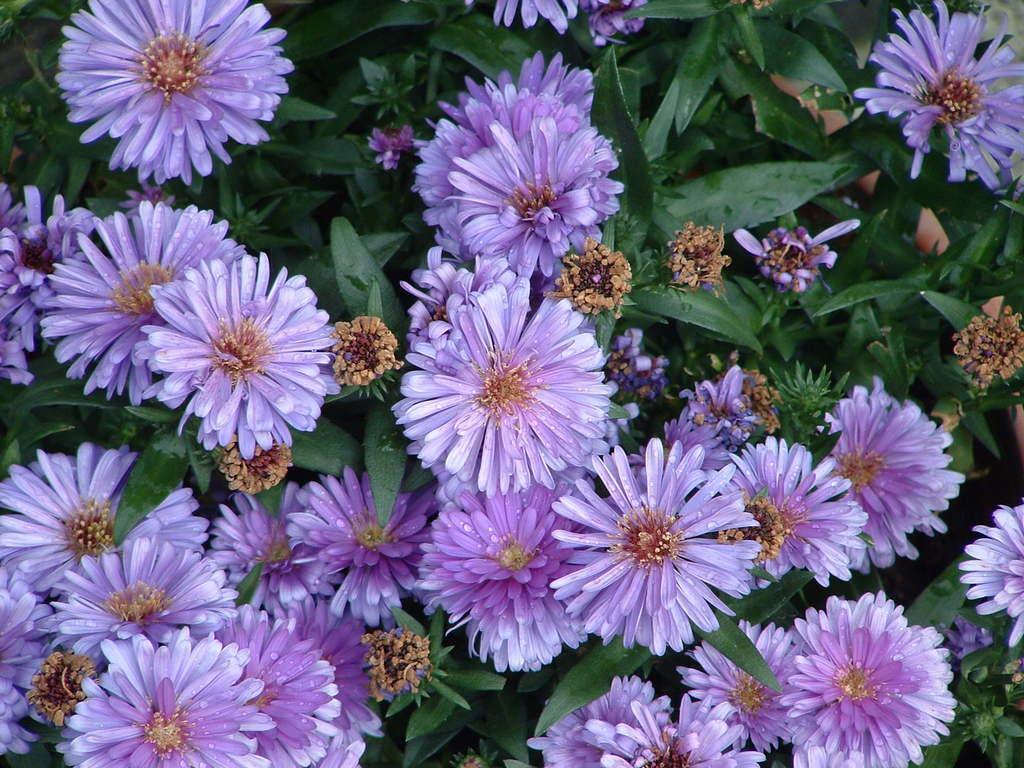Describe this image in one or two sentences. In this picture we can see a group of flowers and leaves. 